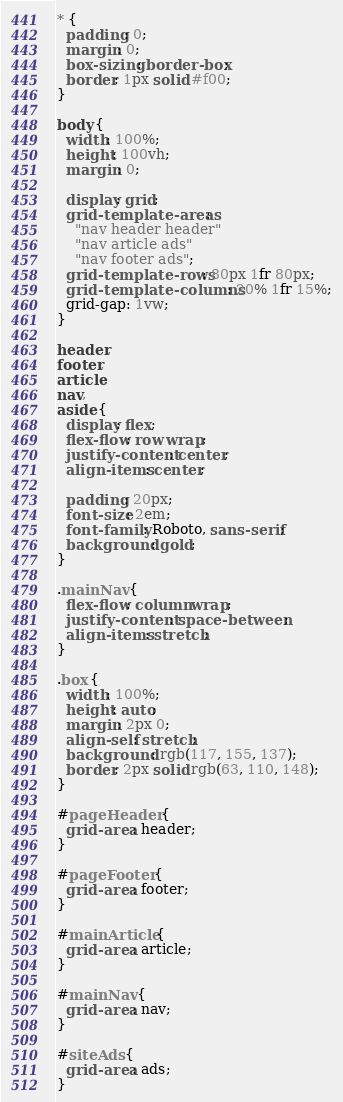Convert code to text. <code><loc_0><loc_0><loc_500><loc_500><_CSS_>* {
  padding: 0;
  margin: 0;
  box-sizing: border-box;
  border: 1px solid #f00;
}

body {
  width: 100%;
  height: 100vh;
  margin: 0;

  display: grid;
  grid-template-areas:
    "nav header header"
    "nav article ads"
    "nav footer ads";
  grid-template-rows: 80px 1fr 80px;
  grid-template-columns: 20% 1fr 15%;
  grid-gap: 1vw;
}

header,
footer,
article,
nav,
aside {
  display: flex;
  flex-flow: row wrap;
  justify-content: center;
  align-items: center;

  padding: 20px;
  font-size: 2em;
  font-family: Roboto, sans-serif;
  background: gold;
}

.mainNav {
  flex-flow: column wrap;
  justify-content: space-between;
  align-items: stretch;
}

.box {
  width: 100%;
  height: auto;
  margin: 2px 0;
  align-self: stretch;
  background: rgb(117, 155, 137);
  border: 2px solid rgb(63, 110, 148);
}

#pageHeader {
  grid-area: header;
}

#pageFooter {
  grid-area: footer;
}

#mainArticle {
  grid-area: article;
}

#mainNav {
  grid-area: nav;
}

#siteAds {
  grid-area: ads;
}
</code> 